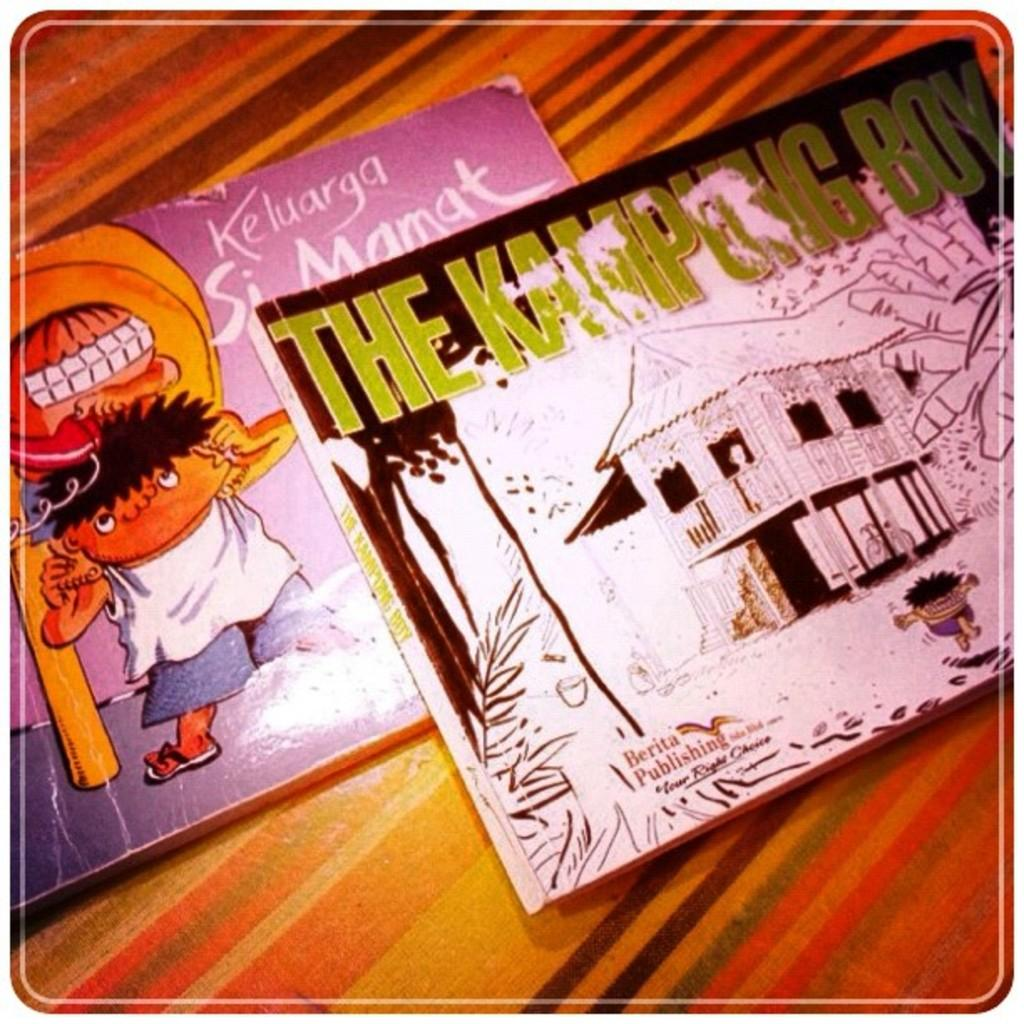Provide a one-sentence caption for the provided image. two childrens books called the kamping and lelugara. 